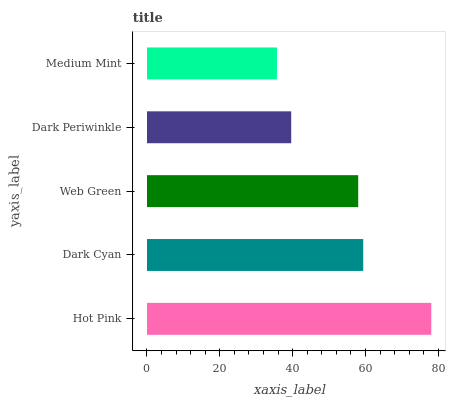Is Medium Mint the minimum?
Answer yes or no. Yes. Is Hot Pink the maximum?
Answer yes or no. Yes. Is Dark Cyan the minimum?
Answer yes or no. No. Is Dark Cyan the maximum?
Answer yes or no. No. Is Hot Pink greater than Dark Cyan?
Answer yes or no. Yes. Is Dark Cyan less than Hot Pink?
Answer yes or no. Yes. Is Dark Cyan greater than Hot Pink?
Answer yes or no. No. Is Hot Pink less than Dark Cyan?
Answer yes or no. No. Is Web Green the high median?
Answer yes or no. Yes. Is Web Green the low median?
Answer yes or no. Yes. Is Dark Periwinkle the high median?
Answer yes or no. No. Is Medium Mint the low median?
Answer yes or no. No. 